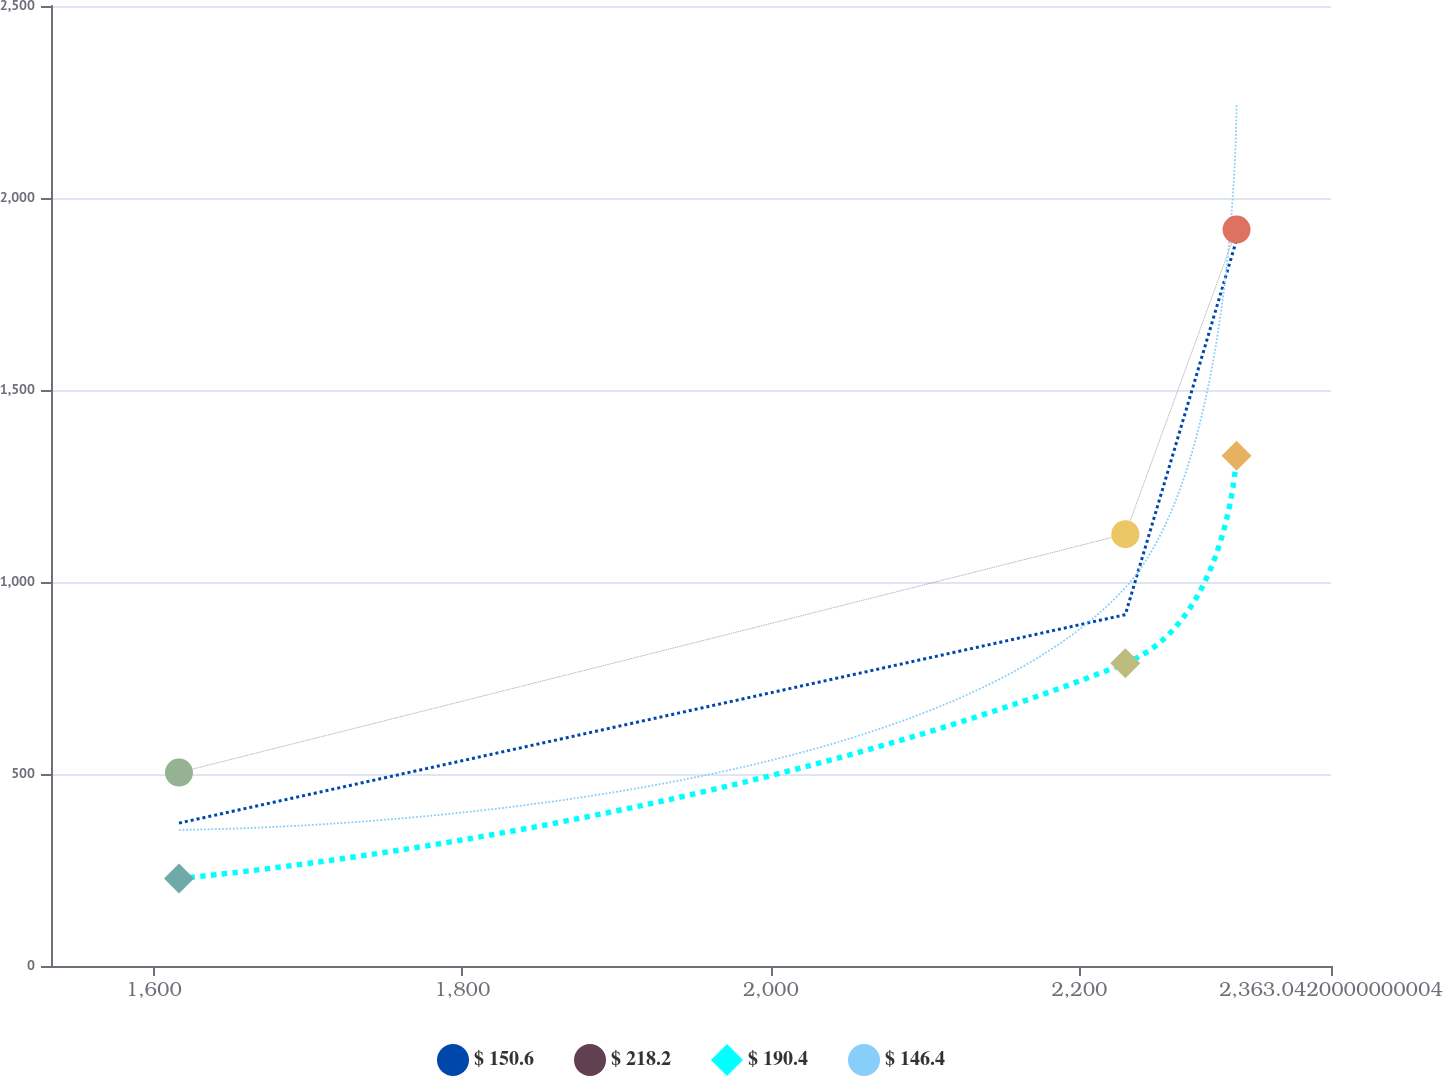Convert chart. <chart><loc_0><loc_0><loc_500><loc_500><line_chart><ecel><fcel>$ 150.6<fcel>$ 218.2<fcel>$ 190.4<fcel>$ 146.4<nl><fcel>1616.33<fcel>372.15<fcel>503.83<fcel>228.11<fcel>354.65<nl><fcel>2229.73<fcel>914.95<fcel>1124.63<fcel>788.32<fcel>985.54<nl><fcel>2301.82<fcel>1890.62<fcel>1917.72<fcel>1329.09<fcel>2246.02<nl><fcel>2373.91<fcel>1222.05<fcel>1363.63<fcel>409.96<fcel>601.98<nl><fcel>2446.01<fcel>1.98<fcel>4.13<fcel>6.76<fcel>9.77<nl></chart> 